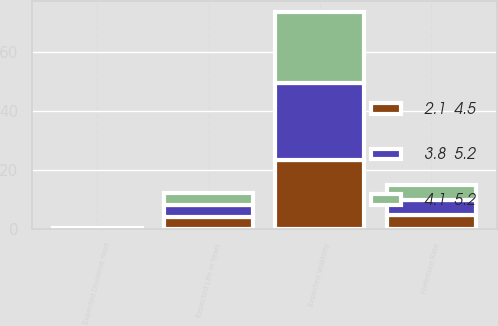<chart> <loc_0><loc_0><loc_500><loc_500><stacked_bar_chart><ecel><fcel>Expected Volatility<fcel>Expected Dividend Yield<fcel>Forfeiture Rate<fcel>Expected Life in Years<nl><fcel>4.1  5.2<fcel>24.2<fcel>0.1<fcel>5<fcel>4.1<nl><fcel>3.8  5.2<fcel>26<fcel>0.1<fcel>5<fcel>4.1<nl><fcel>2.1  4.5<fcel>23.5<fcel>0.1<fcel>5<fcel>4.1<nl></chart> 